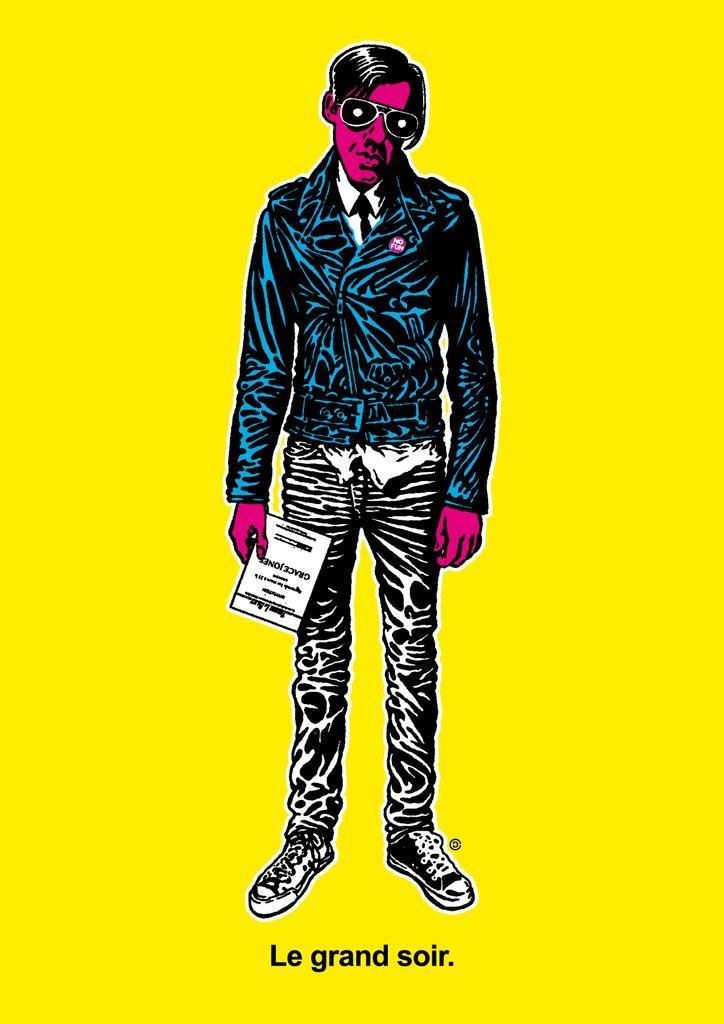Describe this image in one or two sentences. There is an animated image of a person. 